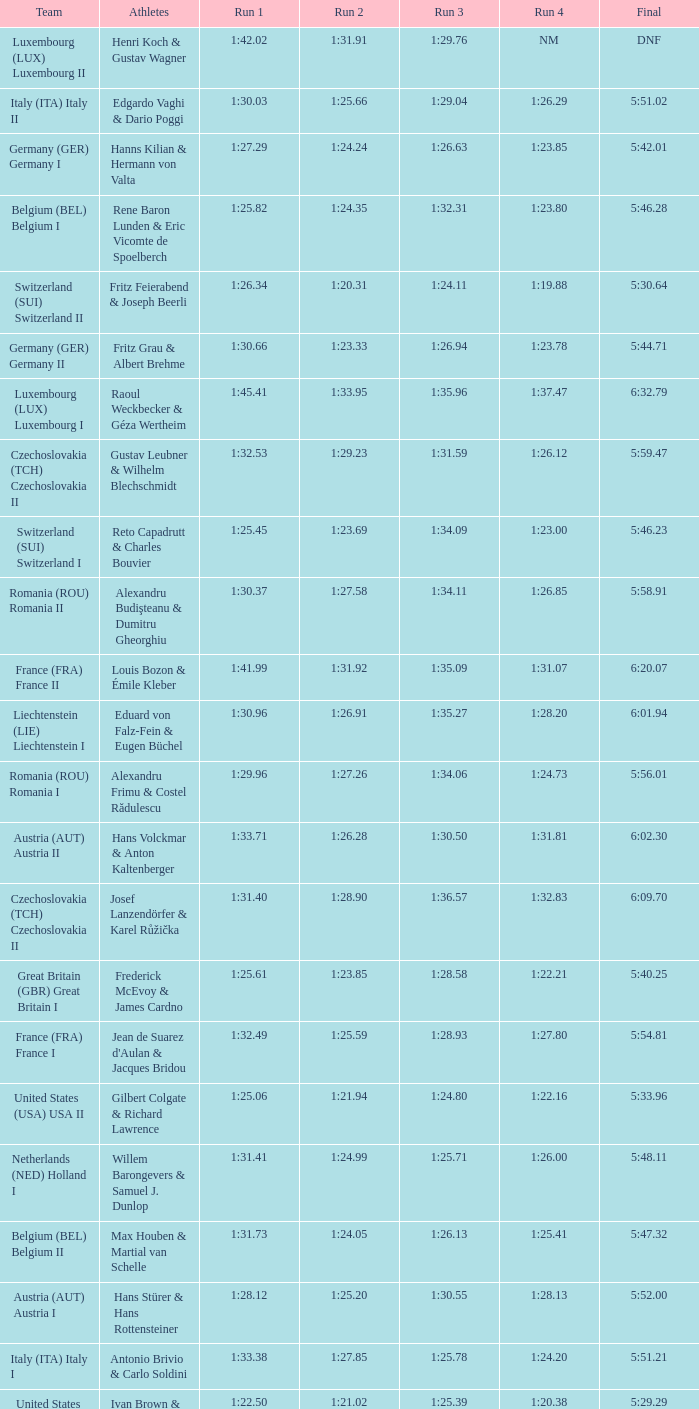Which Run 2 has a Run 1 of 1:30.03? 1:25.66. 